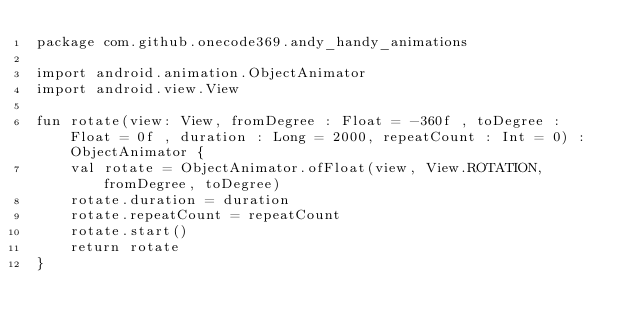Convert code to text. <code><loc_0><loc_0><loc_500><loc_500><_Kotlin_>package com.github.onecode369.andy_handy_animations

import android.animation.ObjectAnimator
import android.view.View

fun rotate(view: View, fromDegree : Float = -360f , toDegree : Float = 0f , duration : Long = 2000, repeatCount : Int = 0) : ObjectAnimator {
    val rotate = ObjectAnimator.ofFloat(view, View.ROTATION, fromDegree, toDegree)
    rotate.duration = duration
    rotate.repeatCount = repeatCount
    rotate.start()
    return rotate
}
</code> 